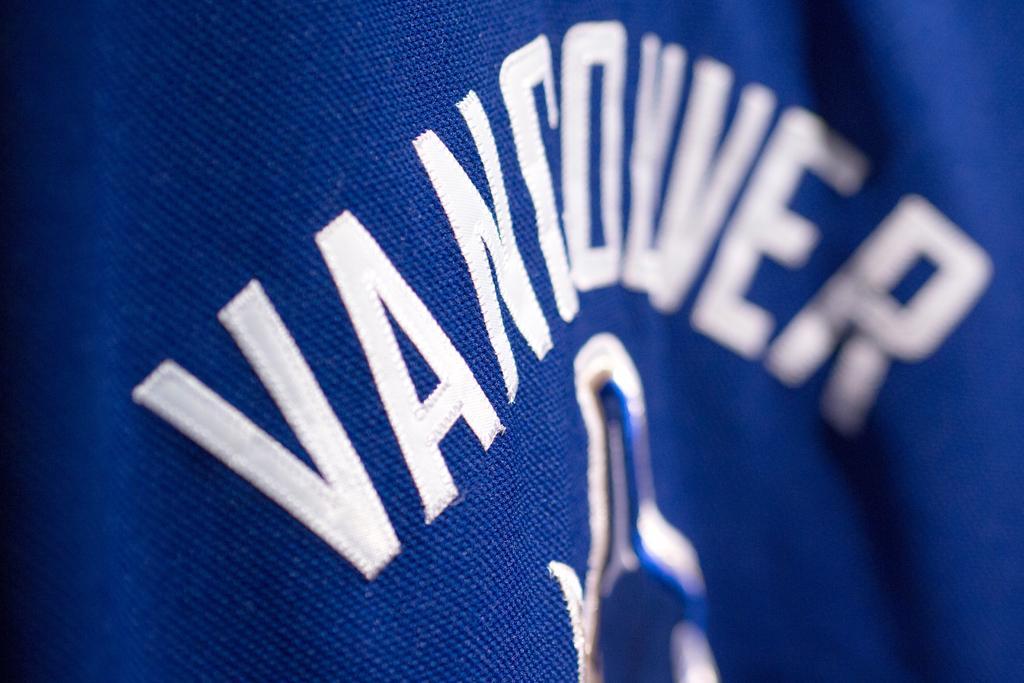How would you summarize this image in a sentence or two? In this image, we can see a blue color t-shirt, there is something printed on the t-shirt. 